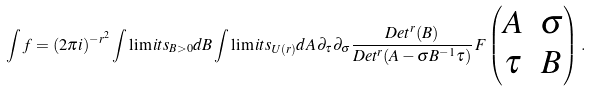Convert formula to latex. <formula><loc_0><loc_0><loc_500><loc_500>\int f = ( 2 \pi i ) ^ { - r ^ { 2 } } \int \lim i t s _ { B > 0 } d B \int \lim i t s _ { U ( r ) } d A \, \partial _ { \tau } \partial _ { \sigma } \frac { D e t ^ { r } ( B ) } { D e t ^ { r } ( A - \sigma B ^ { - 1 } \tau ) } \, F \begin{pmatrix} A & \sigma \\ \tau & B \end{pmatrix} \, .</formula> 